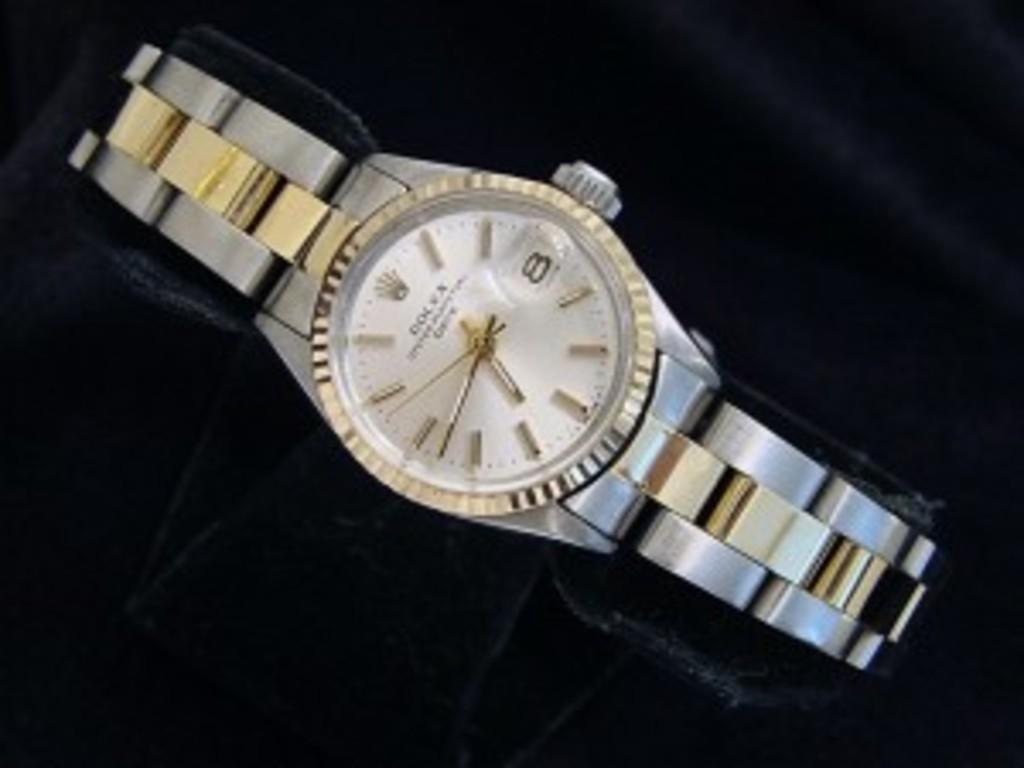<image>
Create a compact narrative representing the image presented. A silver and gold Rolex watch sits against a black background. 